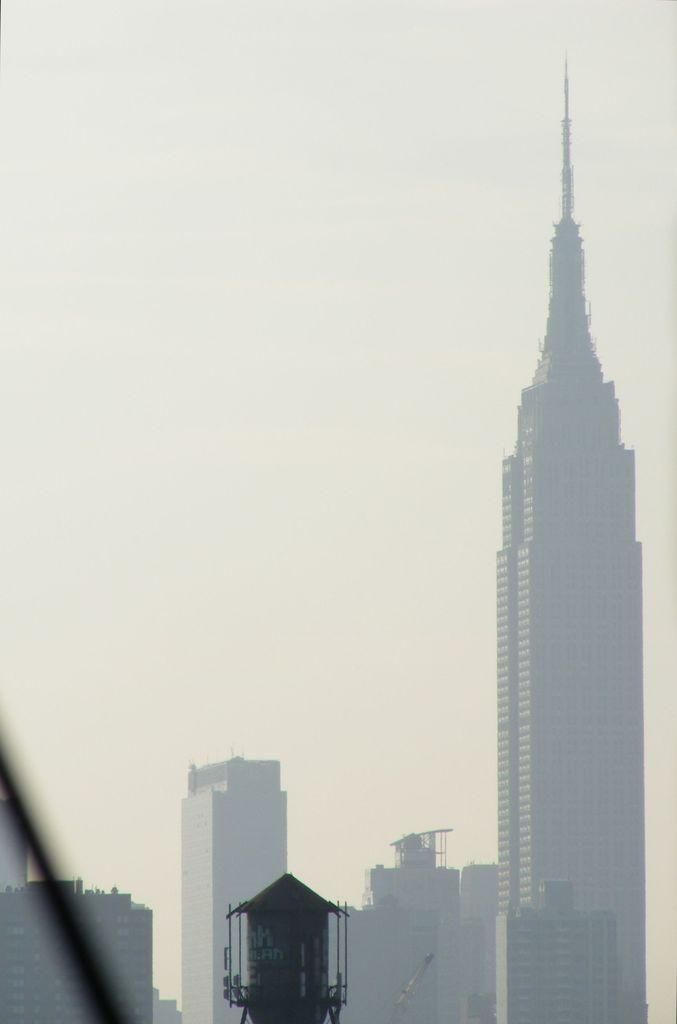What is the primary subject of the image? There are many buildings in the image. What is the color of the sky in the image? The sky is white in color. What type of cloth is being used to make the thunder in the image? There is no cloth or thunder present in the image. What role does the father play in the image? There is no father present in the image. 